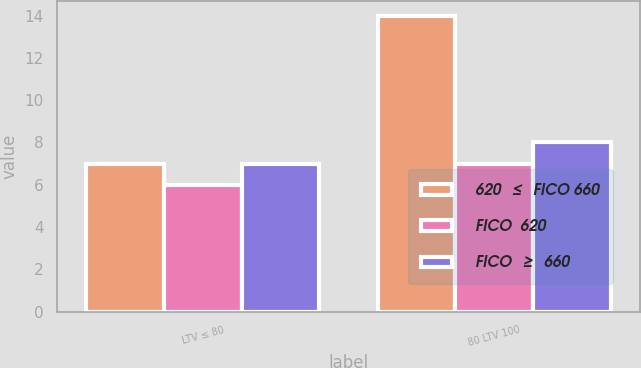Convert chart to OTSL. <chart><loc_0><loc_0><loc_500><loc_500><stacked_bar_chart><ecel><fcel>LTV ≤ 80<fcel>80 LTV 100<nl><fcel>620  ≤  FICO 660<fcel>7<fcel>14<nl><fcel>FICO  620<fcel>6<fcel>7<nl><fcel>FICO  ≥  660<fcel>7<fcel>8<nl></chart> 